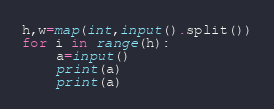<code> <loc_0><loc_0><loc_500><loc_500><_Python_>h,w=map(int,input().split())
for i in range(h):
    a=input()
    print(a)
    print(a)</code> 